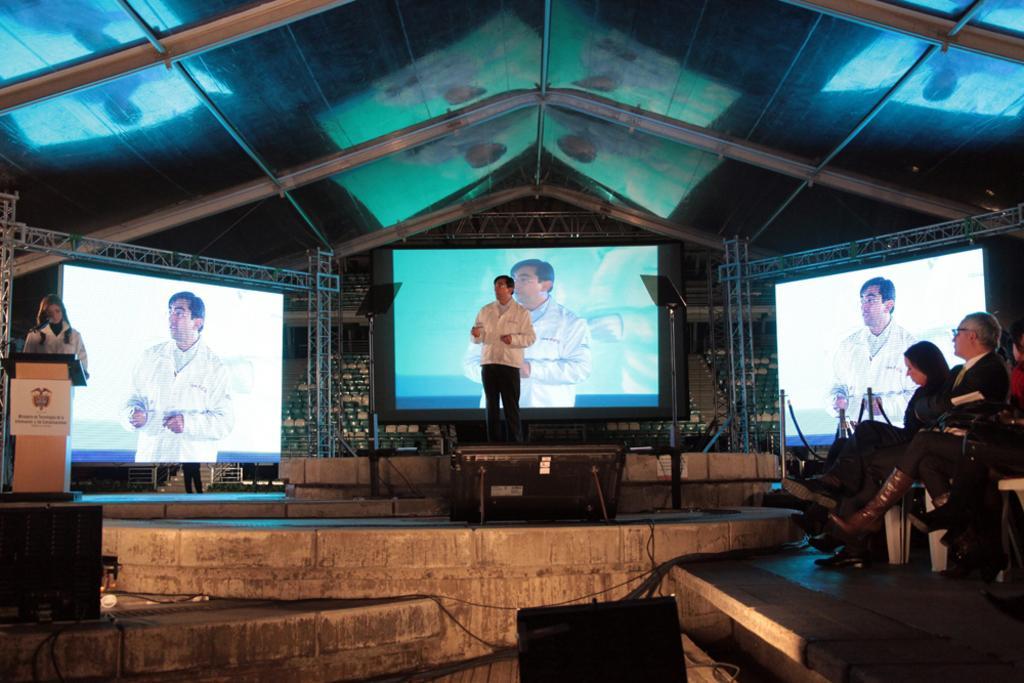How would you summarize this image in a sentence or two? In this image I can see people sitting on the right. A person is standing in the center. A person is standing on the left and there is a podium in front of her. There are 3 display screens at the back. There is roof at the top. 